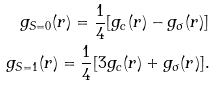Convert formula to latex. <formula><loc_0><loc_0><loc_500><loc_500>g _ { S = 0 } ( r ) = \frac { 1 } { 4 } [ g _ { c } ( r ) - g _ { \sigma } ( r ) ] \\ g _ { S = 1 } ( r ) = \frac { 1 } { 4 } [ 3 g _ { c } ( r ) + g _ { \sigma } ( r ) ] .</formula> 